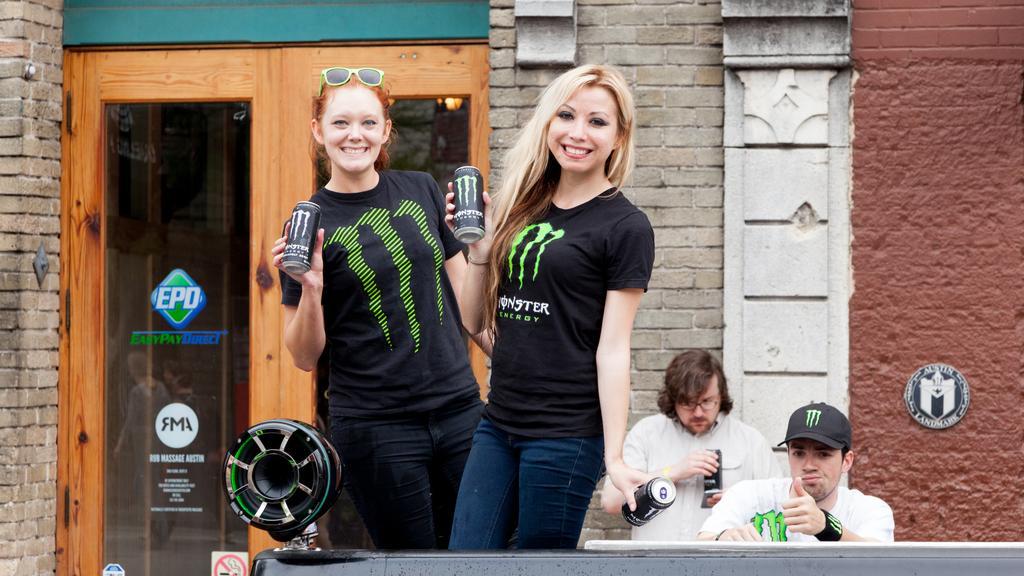Please provide a concise description of this image. In this image there are two girls who are standing one beside the other by holding the tins. In the background there is a door. On the right side there are two men in the background. On the left side there is a speaker. 